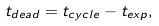<formula> <loc_0><loc_0><loc_500><loc_500>t _ { d e a d } = t _ { c y c l e } - t _ { e x p } ,</formula> 